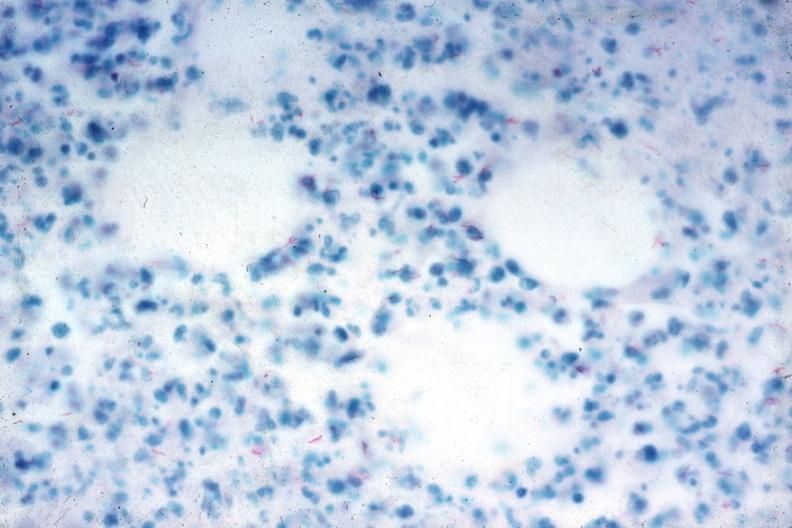does surface show acid fast stain numerous acid fast bacilli very good slide?
Answer the question using a single word or phrase. No 